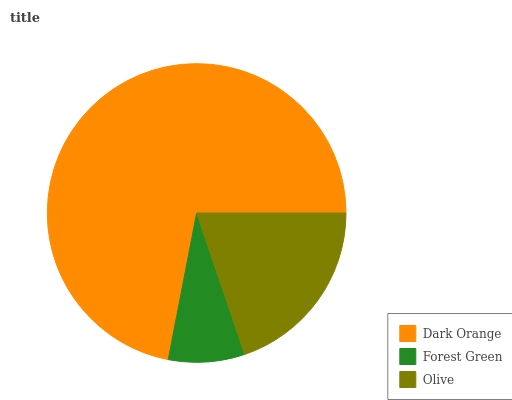Is Forest Green the minimum?
Answer yes or no. Yes. Is Dark Orange the maximum?
Answer yes or no. Yes. Is Olive the minimum?
Answer yes or no. No. Is Olive the maximum?
Answer yes or no. No. Is Olive greater than Forest Green?
Answer yes or no. Yes. Is Forest Green less than Olive?
Answer yes or no. Yes. Is Forest Green greater than Olive?
Answer yes or no. No. Is Olive less than Forest Green?
Answer yes or no. No. Is Olive the high median?
Answer yes or no. Yes. Is Olive the low median?
Answer yes or no. Yes. Is Forest Green the high median?
Answer yes or no. No. Is Forest Green the low median?
Answer yes or no. No. 